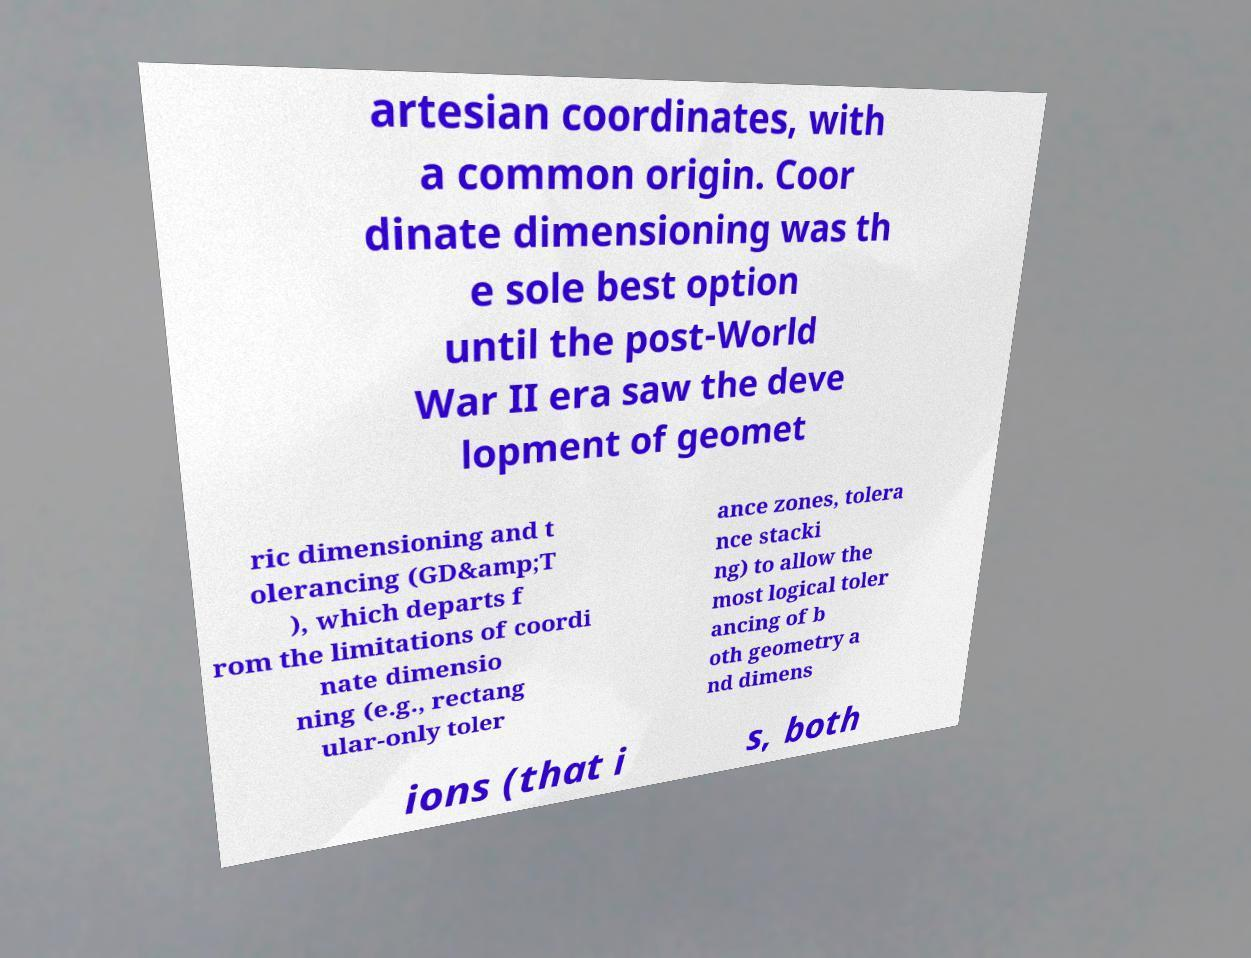For documentation purposes, I need the text within this image transcribed. Could you provide that? artesian coordinates, with a common origin. Coor dinate dimensioning was th e sole best option until the post-World War II era saw the deve lopment of geomet ric dimensioning and t olerancing (GD&amp;T ), which departs f rom the limitations of coordi nate dimensio ning (e.g., rectang ular-only toler ance zones, tolera nce stacki ng) to allow the most logical toler ancing of b oth geometry a nd dimens ions (that i s, both 